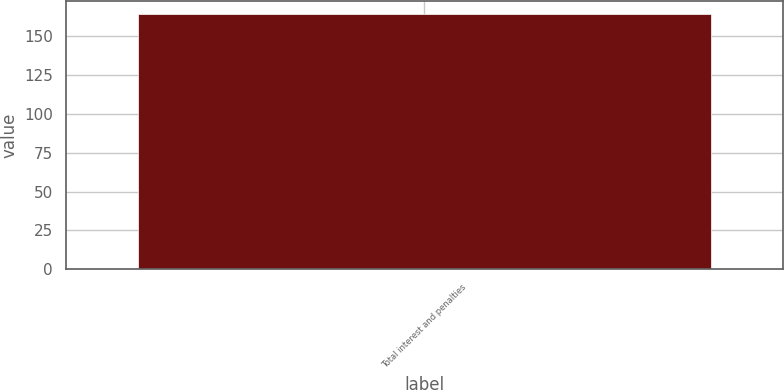<chart> <loc_0><loc_0><loc_500><loc_500><bar_chart><fcel>Total interest and penalties<nl><fcel>164<nl></chart> 